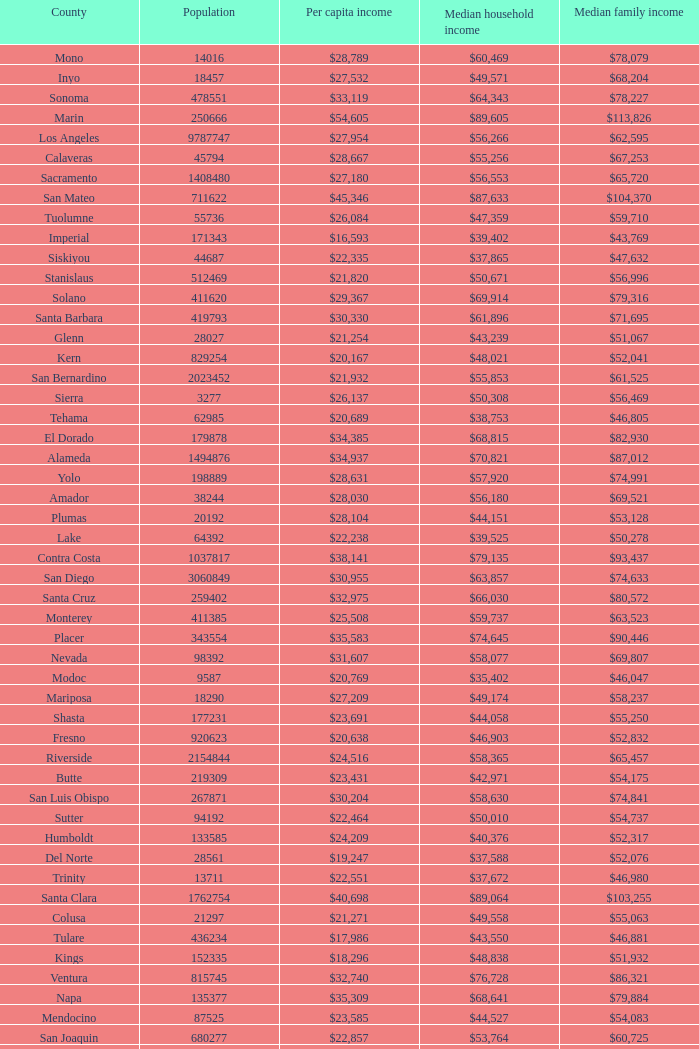What is the median household income of butte? $42,971. 